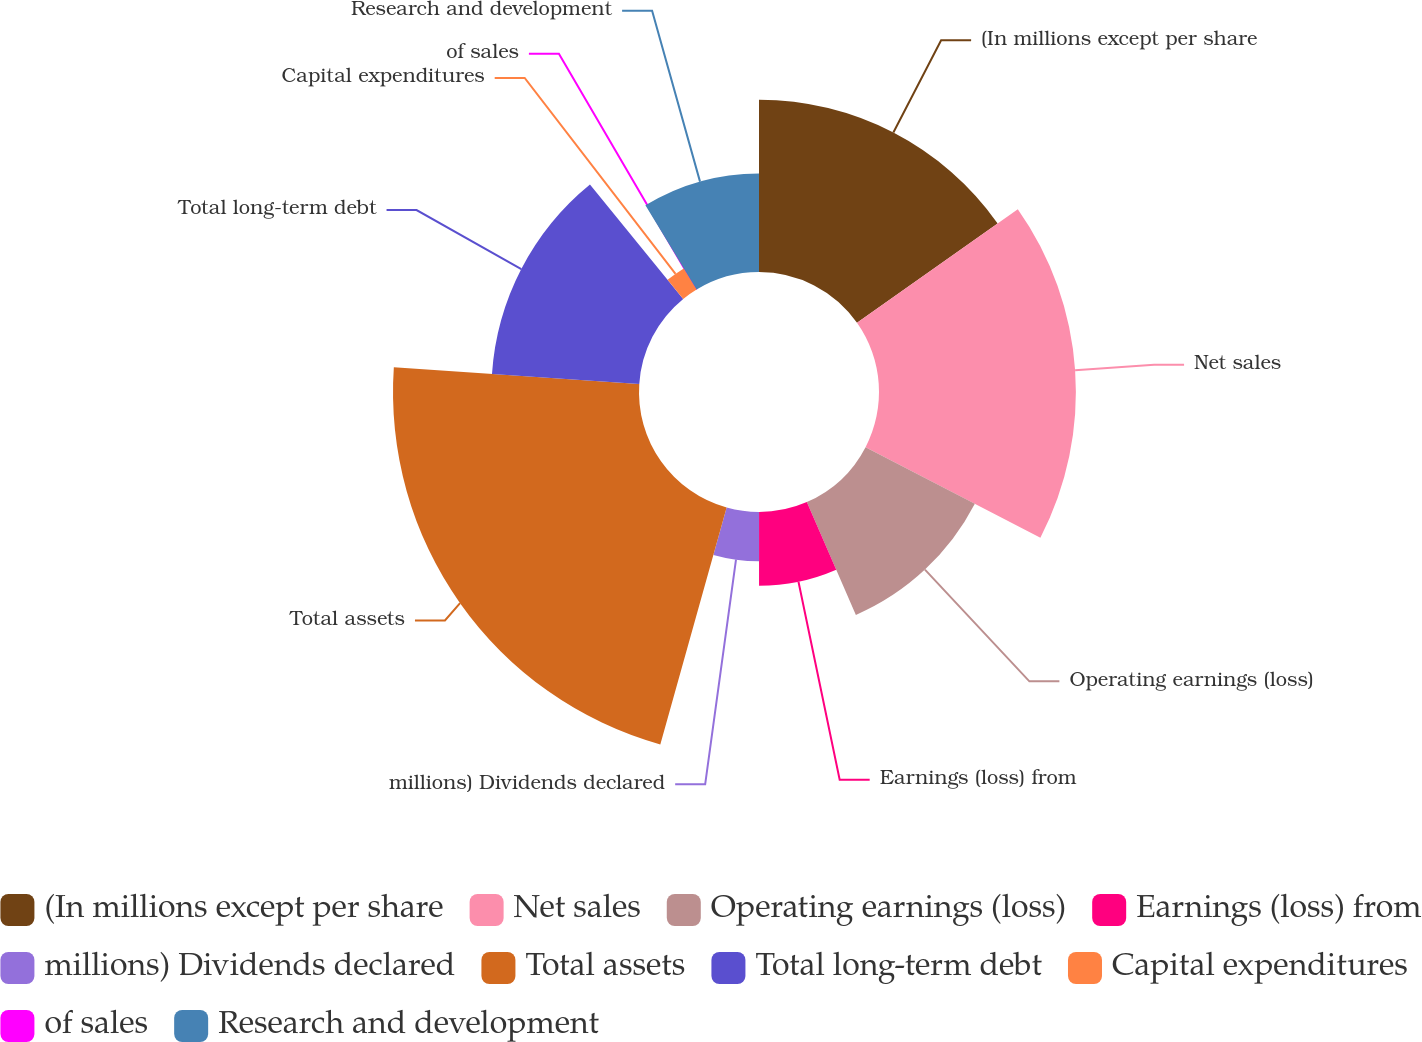<chart> <loc_0><loc_0><loc_500><loc_500><pie_chart><fcel>(In millions except per share<fcel>Net sales<fcel>Operating earnings (loss)<fcel>Earnings (loss) from<fcel>millions) Dividends declared<fcel>Total assets<fcel>Total long-term debt<fcel>Capital expenditures<fcel>of sales<fcel>Research and development<nl><fcel>15.21%<fcel>17.39%<fcel>10.87%<fcel>6.52%<fcel>4.35%<fcel>21.73%<fcel>13.04%<fcel>2.18%<fcel>0.0%<fcel>8.7%<nl></chart> 